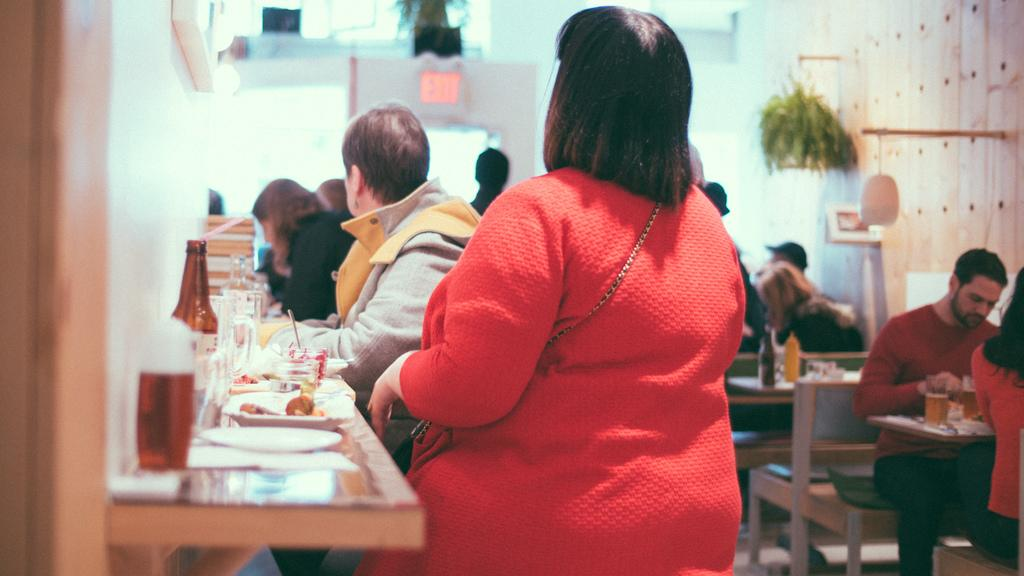What are the people in the image doing? The people in the image are sitting at a table. What can be seen on the table? There are eatables on the table. How are the people arranged in the image? There are people sitting in groups at tables. What type of suit can be seen hanging on the chair in the image? There is no suit visible in the image; people are sitting at tables with eatables on them. 